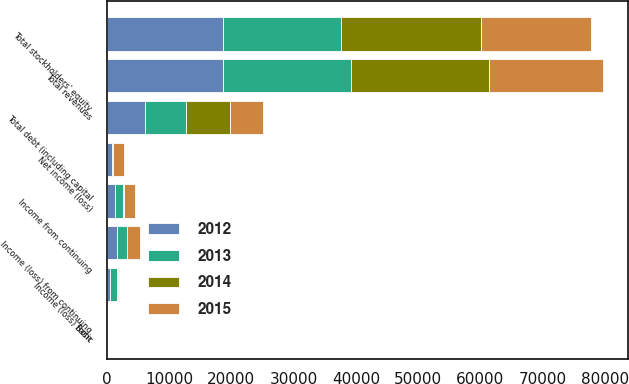Convert chart. <chart><loc_0><loc_0><loc_500><loc_500><stacked_bar_chart><ecel><fcel>Total revenues<fcel>Income (loss) from continuing<fcel>Income from continuing<fcel>Income (loss) from<fcel>Net income (loss)<fcel>Total debt (including capital<fcel>Total stockholders' equity<fcel>Basic<nl><fcel>2015<fcel>18377<fcel>1978<fcel>1673<fcel>9<fcel>1682<fcel>5359<fcel>17642<fcel>4.05<nl><fcel>2012<fcel>18614<fcel>1699<fcel>1349<fcel>551<fcel>798<fcel>6109<fcel>18720<fcel>1.81<nl><fcel>2013<fcel>20673<fcel>1471<fcel>1225<fcel>1049<fcel>176<fcel>6544<fcel>18905<fcel>0.37<nl><fcel>2014<fcel>22086<fcel>89<fcel>220<fcel>258<fcel>38<fcel>7126<fcel>22447<fcel>0.18<nl></chart> 